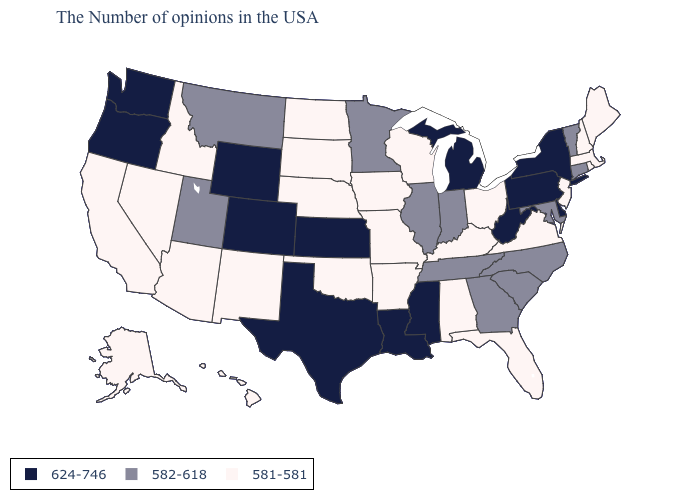Does West Virginia have the highest value in the South?
Write a very short answer. Yes. What is the value of Oklahoma?
Quick response, please. 581-581. Does the map have missing data?
Give a very brief answer. No. Does Missouri have the lowest value in the USA?
Concise answer only. Yes. What is the lowest value in states that border Kentucky?
Short answer required. 581-581. Name the states that have a value in the range 624-746?
Be succinct. New York, Delaware, Pennsylvania, West Virginia, Michigan, Mississippi, Louisiana, Kansas, Texas, Wyoming, Colorado, Washington, Oregon. Does Utah have a higher value than New Mexico?
Answer briefly. Yes. Which states hav the highest value in the South?
Give a very brief answer. Delaware, West Virginia, Mississippi, Louisiana, Texas. Among the states that border Texas , does Oklahoma have the highest value?
Be succinct. No. Name the states that have a value in the range 582-618?
Write a very short answer. Vermont, Connecticut, Maryland, North Carolina, South Carolina, Georgia, Indiana, Tennessee, Illinois, Minnesota, Utah, Montana. Which states hav the highest value in the Northeast?
Quick response, please. New York, Pennsylvania. Name the states that have a value in the range 581-581?
Concise answer only. Maine, Massachusetts, Rhode Island, New Hampshire, New Jersey, Virginia, Ohio, Florida, Kentucky, Alabama, Wisconsin, Missouri, Arkansas, Iowa, Nebraska, Oklahoma, South Dakota, North Dakota, New Mexico, Arizona, Idaho, Nevada, California, Alaska, Hawaii. Does Virginia have a lower value than Delaware?
Short answer required. Yes. Is the legend a continuous bar?
Write a very short answer. No. What is the value of Ohio?
Answer briefly. 581-581. 